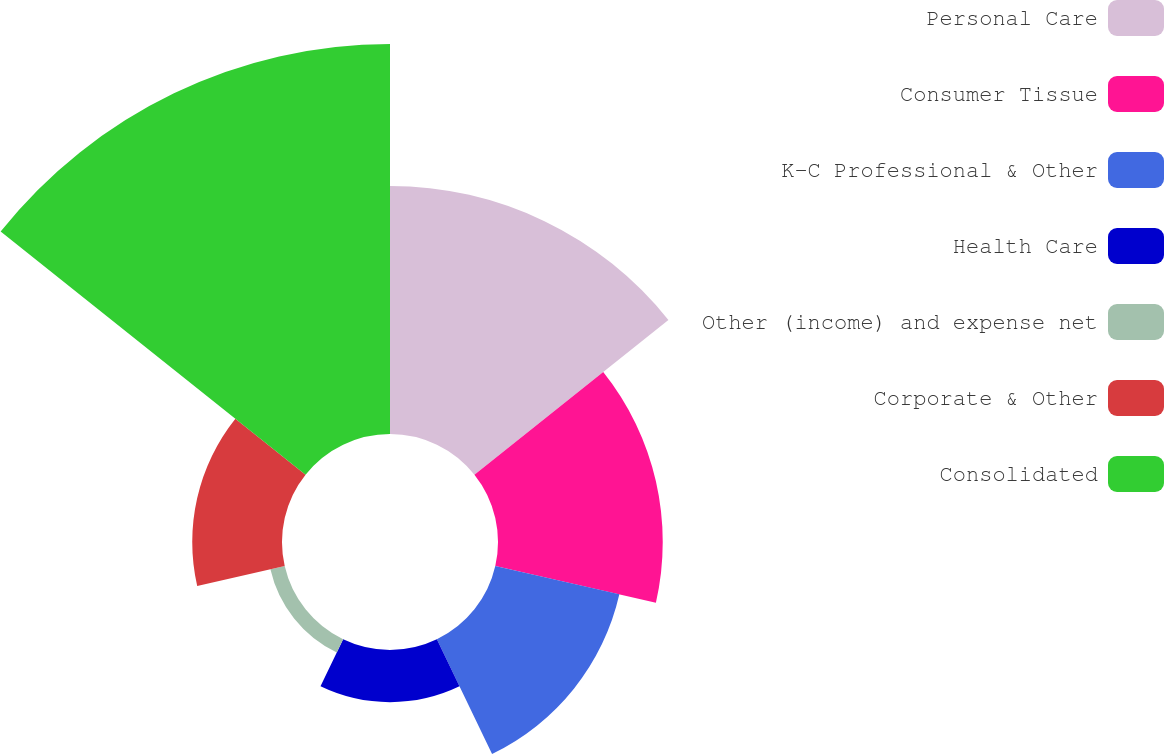Convert chart. <chart><loc_0><loc_0><loc_500><loc_500><pie_chart><fcel>Personal Care<fcel>Consumer Tissue<fcel>K-C Professional & Other<fcel>Health Care<fcel>Other (income) and expense net<fcel>Corporate & Other<fcel>Consolidated<nl><fcel>22.83%<fcel>15.16%<fcel>11.71%<fcel>4.8%<fcel>1.35%<fcel>8.26%<fcel>35.89%<nl></chart> 